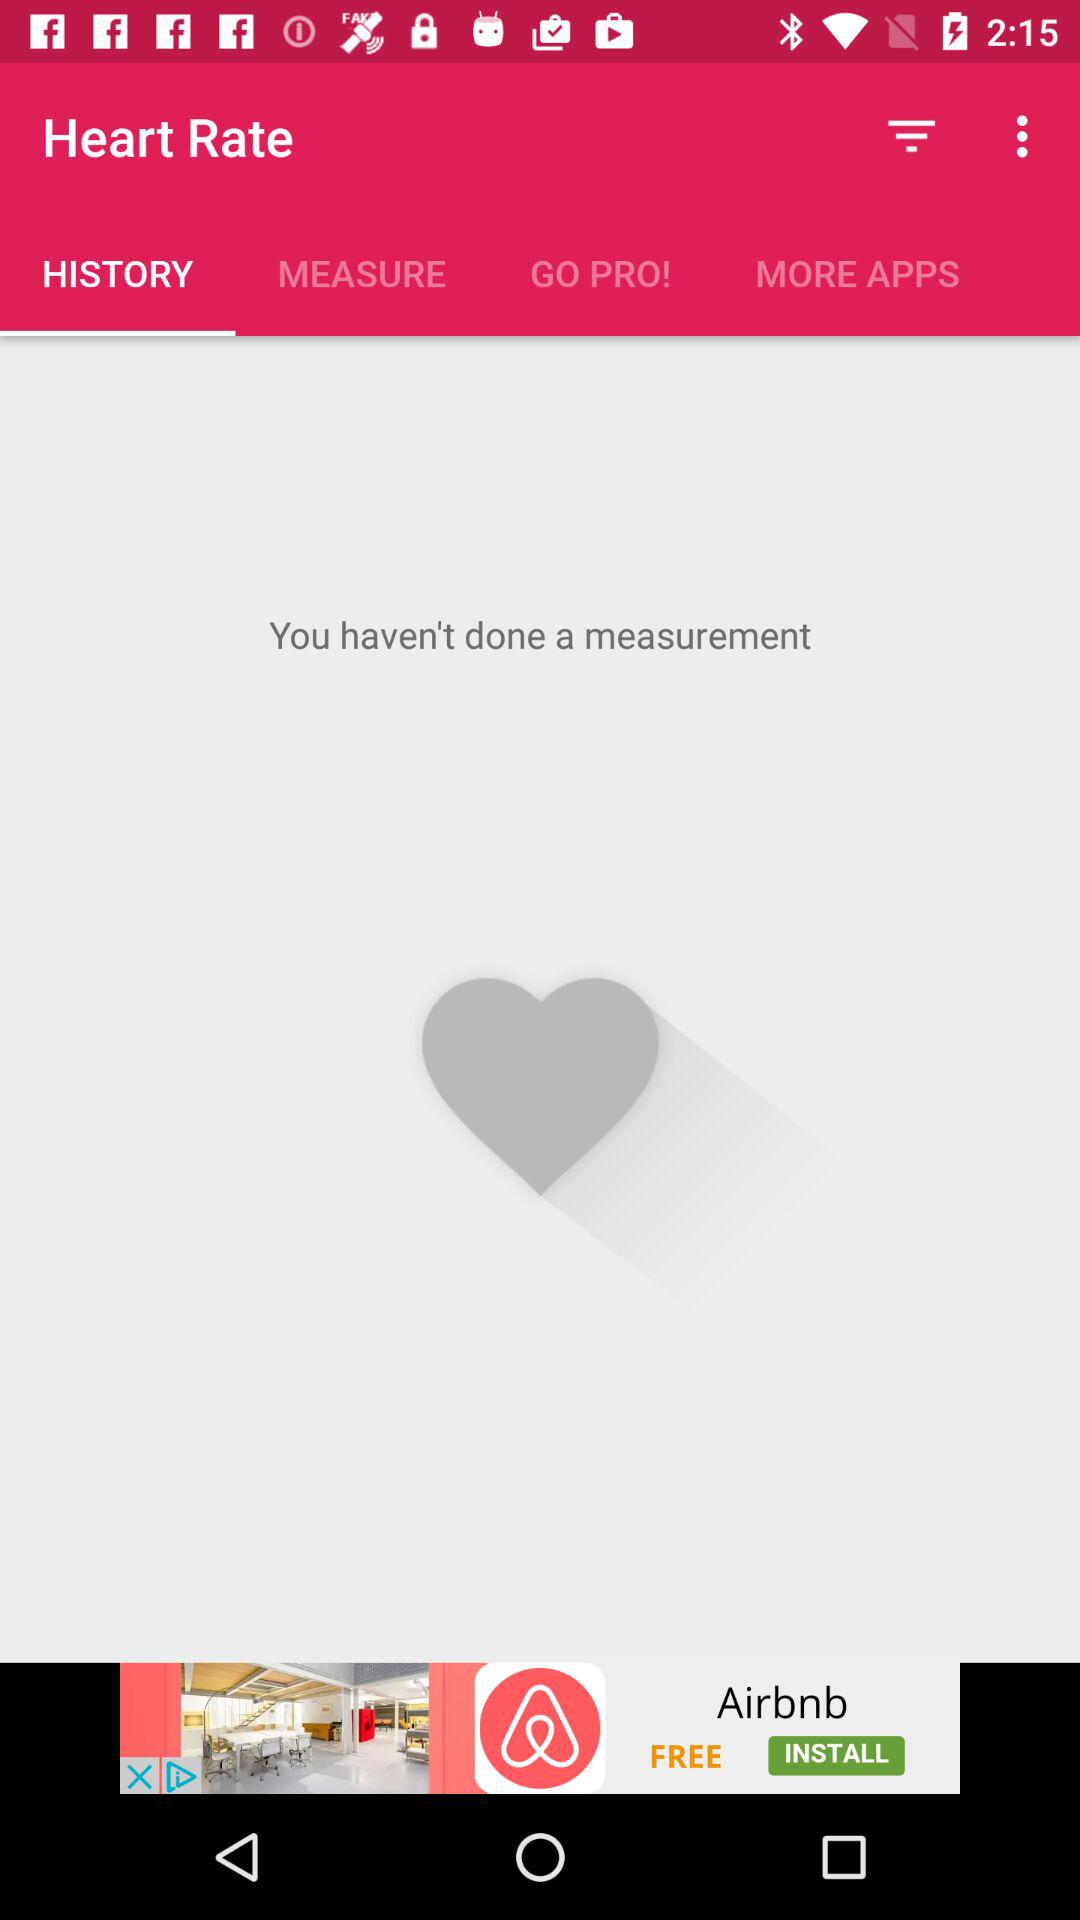Is there any measurement done?
When the provided information is insufficient, respond with <no answer>. <no answer> 